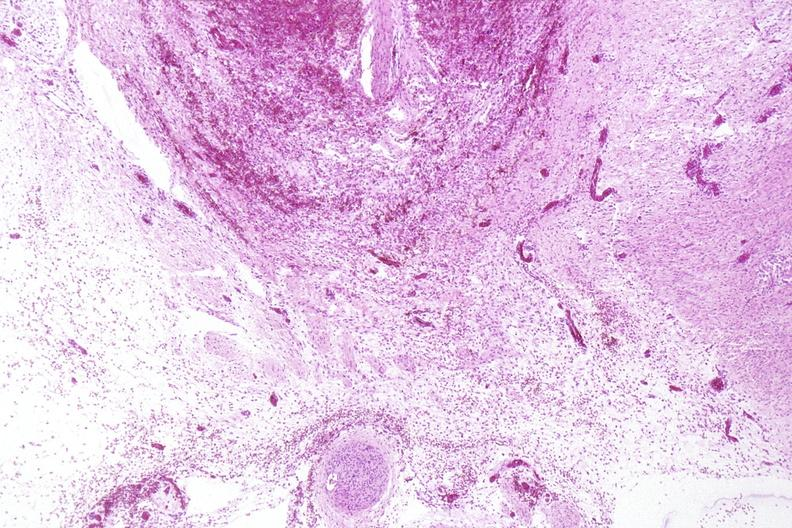what is present?
Answer the question using a single word or phrase. Nervous 